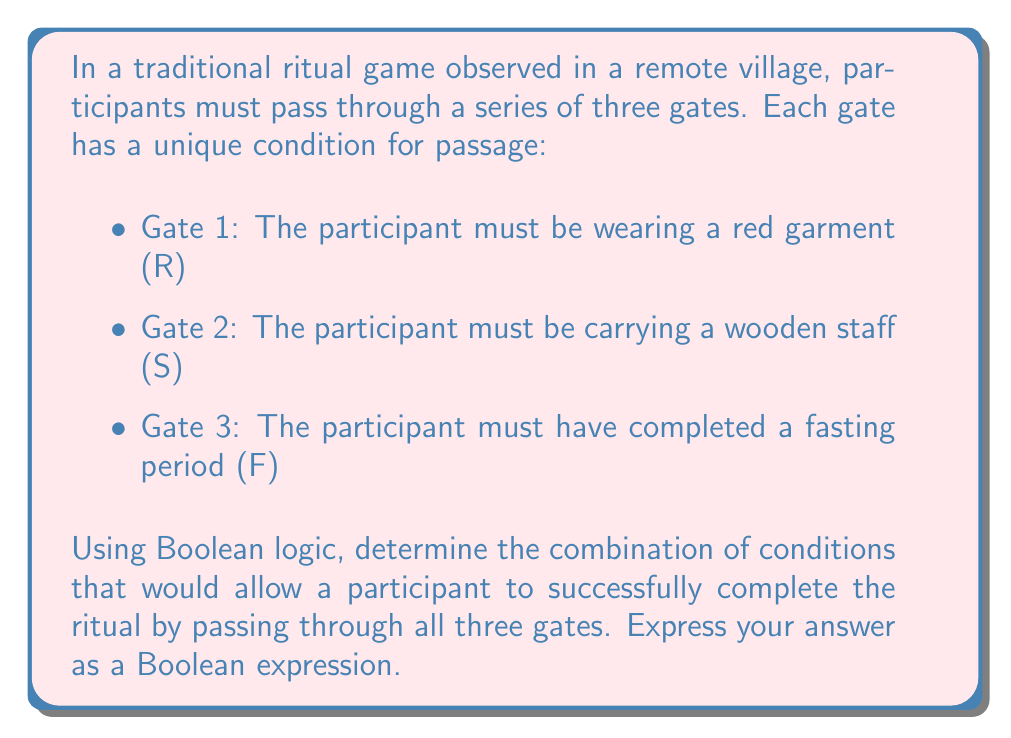Teach me how to tackle this problem. To solve this problem, we need to consider the conditions for each gate and combine them using Boolean logic:

1. For Gate 1: The condition is R (wearing a red garment)
2. For Gate 2: The condition is S (carrying a wooden staff)
3. For Gate 3: The condition is F (completed fasting period)

To successfully complete the ritual, a participant must satisfy all three conditions. In Boolean logic, when all conditions must be met, we use the AND operator, which is typically represented by the symbol $\land$.

Therefore, the Boolean expression for successfully completing the ritual is:

$$ R \land S \land F $$

This expression means that a participant must satisfy condition R AND condition S AND condition F to pass through all three gates and complete the ritual.

In cultural anthropology, this Boolean model represents the decision-making process embedded in the ritual, where each gate acts as a cultural filter, ensuring that only participants who have fulfilled all required conditions can complete the ceremony.
Answer: $$ R \land S \land F $$ 